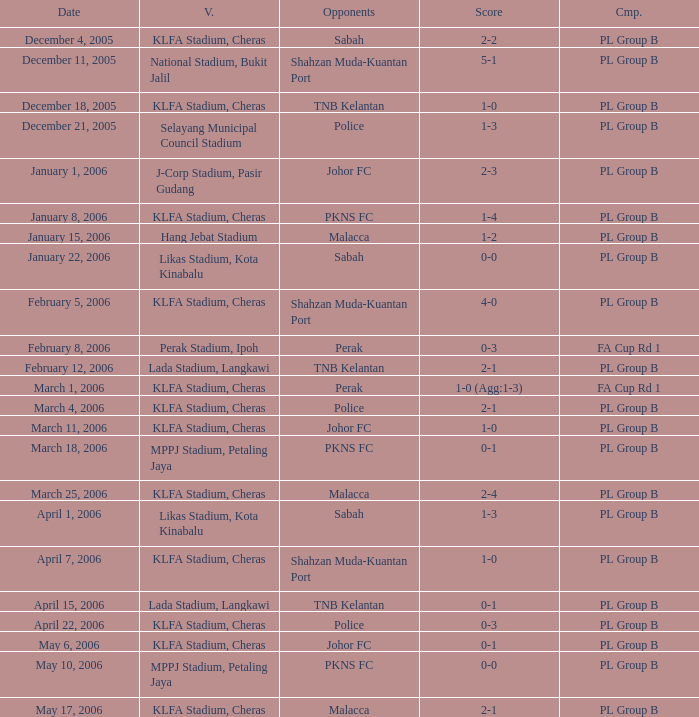Which Date has a Competition of pl group b, and Opponents of police, and a Venue of selayang municipal council stadium? December 21, 2005. 